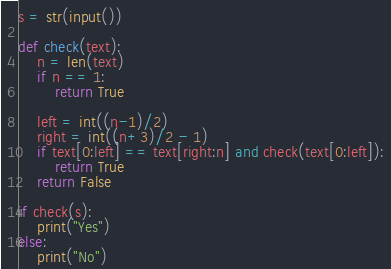Convert code to text. <code><loc_0><loc_0><loc_500><loc_500><_Python_>s = str(input())

def check(text):
    n = len(text)
    if n == 1:
        return True

    left = int((n-1)/2)
    right = int((n+3)/2 - 1)
    if text[0:left] == text[right:n] and check(text[0:left]):
        return True
    return False

if check(s):
    print("Yes")
else:
    print("No")
</code> 